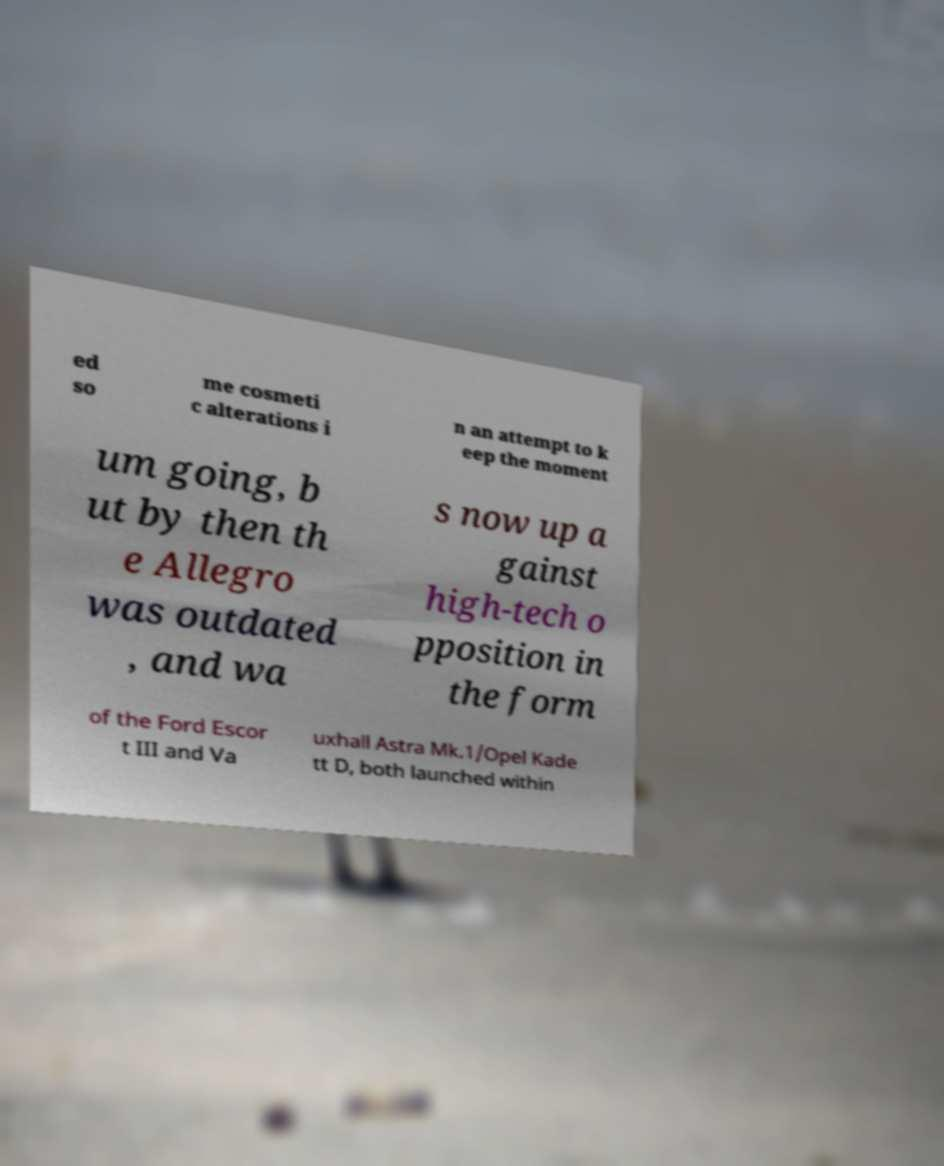Please read and relay the text visible in this image. What does it say? ed so me cosmeti c alterations i n an attempt to k eep the moment um going, b ut by then th e Allegro was outdated , and wa s now up a gainst high-tech o pposition in the form of the Ford Escor t III and Va uxhall Astra Mk.1/Opel Kade tt D, both launched within 